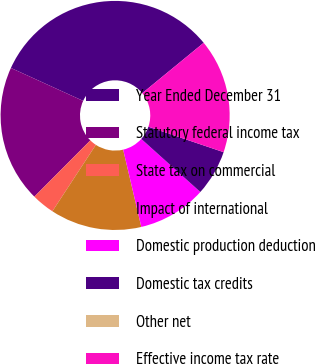Convert chart to OTSL. <chart><loc_0><loc_0><loc_500><loc_500><pie_chart><fcel>Year Ended December 31<fcel>Statutory federal income tax<fcel>State tax on commercial<fcel>Impact of international<fcel>Domestic production deduction<fcel>Domestic tax credits<fcel>Other net<fcel>Effective income tax rate<nl><fcel>32.26%<fcel>19.35%<fcel>3.23%<fcel>12.9%<fcel>9.68%<fcel>6.45%<fcel>0.0%<fcel>16.13%<nl></chart> 